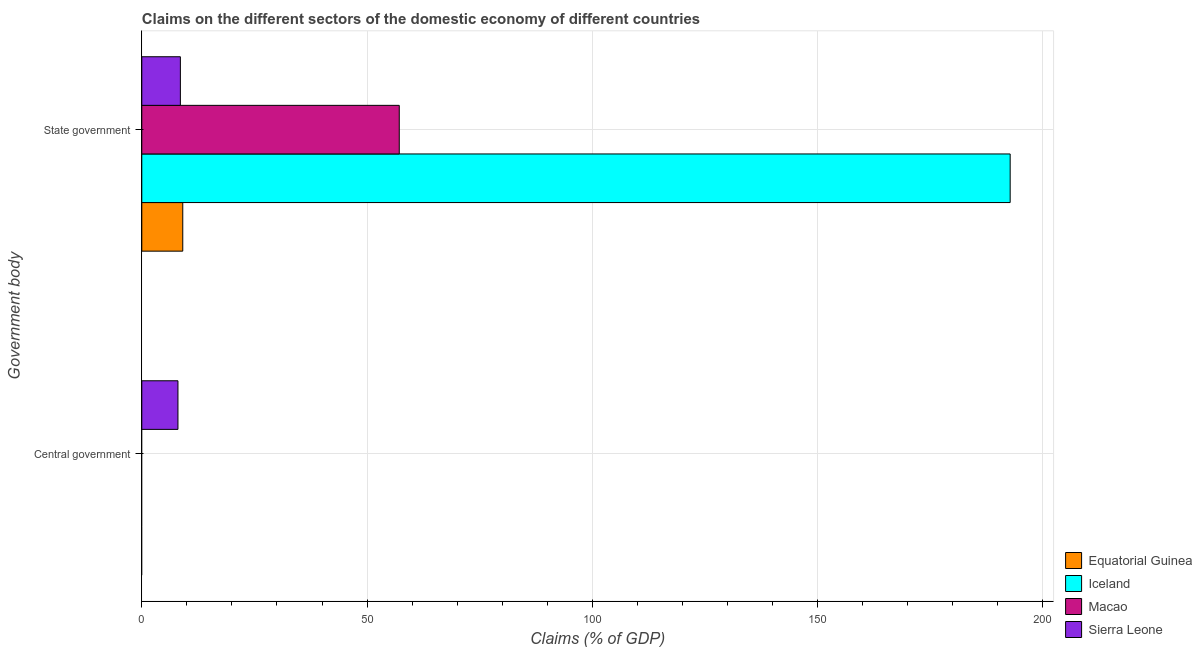What is the label of the 1st group of bars from the top?
Your response must be concise. State government. Across all countries, what is the maximum claims on central government?
Offer a terse response. 8.02. Across all countries, what is the minimum claims on state government?
Make the answer very short. 8.56. In which country was the claims on state government maximum?
Provide a short and direct response. Iceland. What is the total claims on state government in the graph?
Give a very brief answer. 267.53. What is the difference between the claims on state government in Sierra Leone and that in Iceland?
Your answer should be compact. -184.17. What is the difference between the claims on state government in Macao and the claims on central government in Iceland?
Ensure brevity in your answer.  57.14. What is the average claims on state government per country?
Keep it short and to the point. 66.88. What is the difference between the claims on central government and claims on state government in Sierra Leone?
Keep it short and to the point. -0.54. What is the ratio of the claims on state government in Equatorial Guinea to that in Macao?
Give a very brief answer. 0.16. Is the claims on state government in Macao less than that in Iceland?
Give a very brief answer. Yes. In how many countries, is the claims on central government greater than the average claims on central government taken over all countries?
Your answer should be compact. 1. Are all the bars in the graph horizontal?
Keep it short and to the point. Yes. How many countries are there in the graph?
Keep it short and to the point. 4. What is the difference between two consecutive major ticks on the X-axis?
Make the answer very short. 50. Does the graph contain any zero values?
Offer a terse response. Yes. Does the graph contain grids?
Offer a very short reply. Yes. Where does the legend appear in the graph?
Your answer should be compact. Bottom right. How many legend labels are there?
Give a very brief answer. 4. What is the title of the graph?
Your response must be concise. Claims on the different sectors of the domestic economy of different countries. What is the label or title of the X-axis?
Your response must be concise. Claims (% of GDP). What is the label or title of the Y-axis?
Offer a very short reply. Government body. What is the Claims (% of GDP) of Macao in Central government?
Make the answer very short. 0. What is the Claims (% of GDP) of Sierra Leone in Central government?
Provide a succinct answer. 8.02. What is the Claims (% of GDP) of Equatorial Guinea in State government?
Make the answer very short. 9.09. What is the Claims (% of GDP) of Iceland in State government?
Your response must be concise. 192.73. What is the Claims (% of GDP) in Macao in State government?
Provide a short and direct response. 57.14. What is the Claims (% of GDP) in Sierra Leone in State government?
Your answer should be compact. 8.56. Across all Government body, what is the maximum Claims (% of GDP) of Equatorial Guinea?
Keep it short and to the point. 9.09. Across all Government body, what is the maximum Claims (% of GDP) in Iceland?
Keep it short and to the point. 192.73. Across all Government body, what is the maximum Claims (% of GDP) in Macao?
Offer a very short reply. 57.14. Across all Government body, what is the maximum Claims (% of GDP) in Sierra Leone?
Keep it short and to the point. 8.56. Across all Government body, what is the minimum Claims (% of GDP) in Iceland?
Keep it short and to the point. 0. Across all Government body, what is the minimum Claims (% of GDP) in Sierra Leone?
Provide a short and direct response. 8.02. What is the total Claims (% of GDP) of Equatorial Guinea in the graph?
Offer a terse response. 9.09. What is the total Claims (% of GDP) in Iceland in the graph?
Make the answer very short. 192.73. What is the total Claims (% of GDP) of Macao in the graph?
Ensure brevity in your answer.  57.14. What is the total Claims (% of GDP) of Sierra Leone in the graph?
Offer a very short reply. 16.58. What is the difference between the Claims (% of GDP) of Sierra Leone in Central government and that in State government?
Give a very brief answer. -0.54. What is the average Claims (% of GDP) in Equatorial Guinea per Government body?
Your response must be concise. 4.55. What is the average Claims (% of GDP) of Iceland per Government body?
Your answer should be compact. 96.37. What is the average Claims (% of GDP) of Macao per Government body?
Your answer should be very brief. 28.57. What is the average Claims (% of GDP) of Sierra Leone per Government body?
Provide a succinct answer. 8.29. What is the difference between the Claims (% of GDP) of Equatorial Guinea and Claims (% of GDP) of Iceland in State government?
Offer a very short reply. -183.64. What is the difference between the Claims (% of GDP) in Equatorial Guinea and Claims (% of GDP) in Macao in State government?
Your response must be concise. -48.05. What is the difference between the Claims (% of GDP) of Equatorial Guinea and Claims (% of GDP) of Sierra Leone in State government?
Ensure brevity in your answer.  0.53. What is the difference between the Claims (% of GDP) of Iceland and Claims (% of GDP) of Macao in State government?
Offer a terse response. 135.59. What is the difference between the Claims (% of GDP) of Iceland and Claims (% of GDP) of Sierra Leone in State government?
Provide a short and direct response. 184.17. What is the difference between the Claims (% of GDP) in Macao and Claims (% of GDP) in Sierra Leone in State government?
Provide a succinct answer. 48.58. What is the ratio of the Claims (% of GDP) in Sierra Leone in Central government to that in State government?
Your answer should be compact. 0.94. What is the difference between the highest and the second highest Claims (% of GDP) in Sierra Leone?
Offer a very short reply. 0.54. What is the difference between the highest and the lowest Claims (% of GDP) of Equatorial Guinea?
Provide a succinct answer. 9.09. What is the difference between the highest and the lowest Claims (% of GDP) in Iceland?
Offer a terse response. 192.73. What is the difference between the highest and the lowest Claims (% of GDP) of Macao?
Offer a terse response. 57.14. What is the difference between the highest and the lowest Claims (% of GDP) of Sierra Leone?
Ensure brevity in your answer.  0.54. 